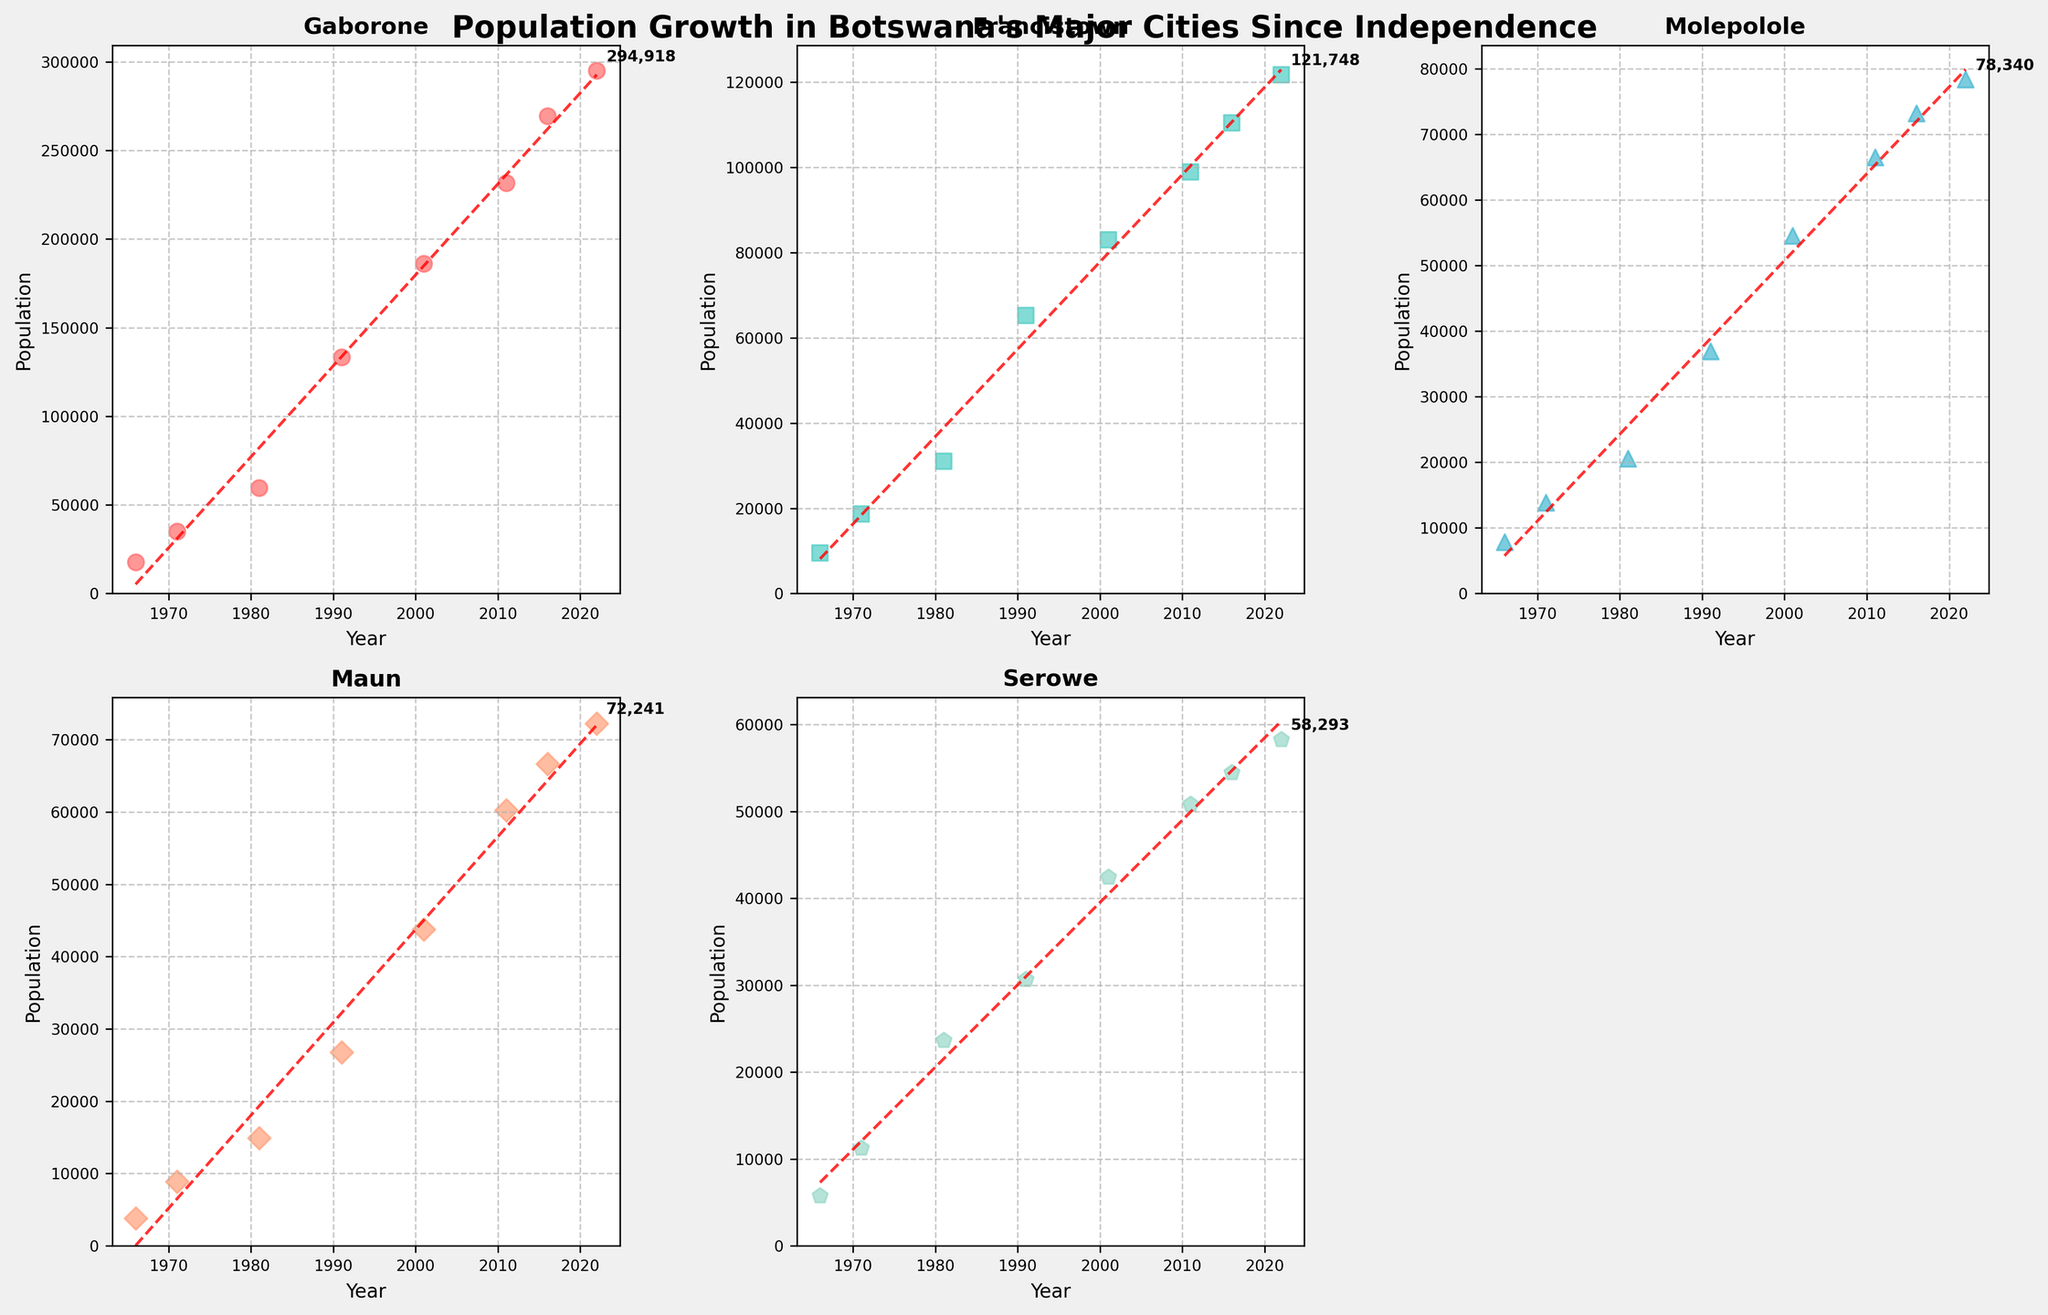What city had the highest population in 2022? Firstly, identify the data points for the year 2022 in each city's subplot. Gaborone shows the highest population of 294,918 in 2022.
Answer: Gaborone Which city's population shows the greatest overall increase from 1966 to 2022? Calculate the difference between the population in 2022 and 1966 for each city by visually inspecting the endpoints of the scatter plot trend lines. Gaborone has the greatest increase.
Answer: Gaborone In which city did the population grow the slowest between 2011 and 2016? Compare the slopes of the data points between the years 2011 and 2016 for all cities' plots. Serowe shows the smallest increase in population during this period.
Answer: Serowe What is the approximate population of Maun in 1991? Locate the plot for Maun and find the population corresponding to the year 1991. The population is around 26,768.
Answer: 26,768 On the plot for Francistown, what does the red dashed line represent? The red dashed line represents a trend line obtained from fitting a straight line to the population data points, showing the general increase in population over time.
Answer: Trend line Which two cities had nearly equal populations in 2001? Compare the data points for all cities in the year 2001. Both Francistown (83,023) and Molepolole (54,561) had nearly equal populations.
Answer: Francistown and Molepolole By approximately how much did the population of Gaborone increase from 2001 to 2011? By subtracting Gaborone's population in 2011 (231,592) from that in 2001 (186,007), you estimate the increase, which is approximately 45,585.
Answer: 45,585 Which city has the smallest final annotation on its scatter plot, and what is the value? Look at the last population annotation for each city's subplot. Serowe has the smallest annotation with a population of 58,293.
Answer: Serowe, 58,293 